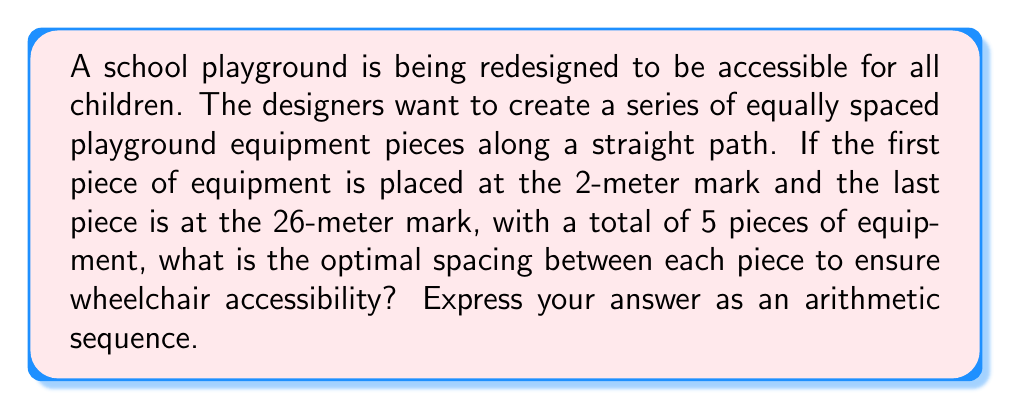Teach me how to tackle this problem. Let's approach this step-by-step:

1) We're dealing with an arithmetic sequence, where the spacing between each term is constant. Let's call this common difference $d$.

2) We know:
   - The first term $a_1 = 2$ (2-meter mark)
   - The last term $a_5 = 26$ (26-meter mark)
   - The number of terms $n = 5$

3) In an arithmetic sequence, the last term can be expressed as:
   $$a_n = a_1 + (n-1)d$$

4) Substituting our known values:
   $$26 = 2 + (5-1)d$$

5) Simplifying:
   $$26 = 2 + 4d$$
   $$24 = 4d$$
   $$d = 6$$

6) Therefore, the common difference (spacing) is 6 meters.

7) We can now write our arithmetic sequence:
   $$a_n = 2 + (n-1)6$$
   
   Which simplifies to:
   $$a_n = 2 + 6n - 6$$
   $$a_n = 6n - 4$$

8) This sequence represents the optimal spacing for the 5 pieces of equipment:
   - $a_1 = 6(1) - 4 = 2$
   - $a_2 = 6(2) - 4 = 8$
   - $a_3 = 6(3) - 4 = 14$
   - $a_4 = 6(4) - 4 = 20$
   - $a_5 = 6(5) - 4 = 26$
Answer: $a_n = 6n - 4$ 